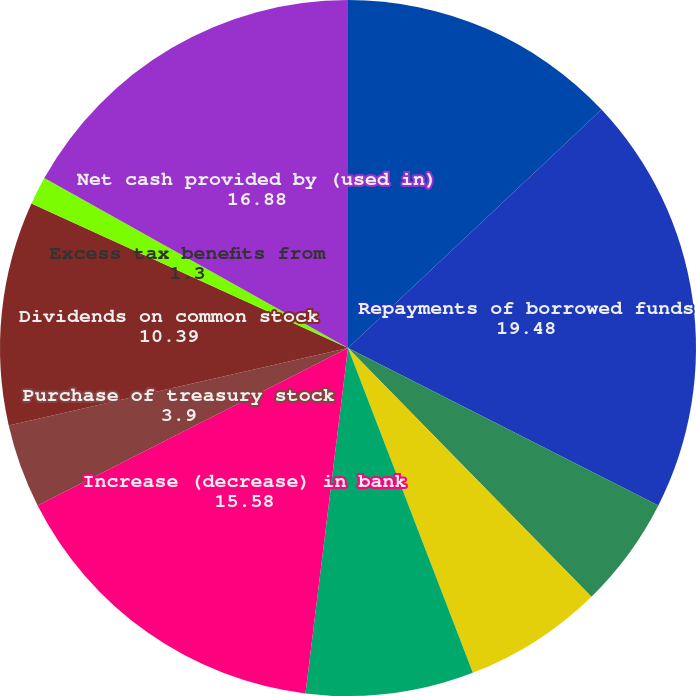Convert chart. <chart><loc_0><loc_0><loc_500><loc_500><pie_chart><fcel>Proceeds from borrowed funds<fcel>Repayments of borrowed funds<fcel>Repayments of borrowings by<fcel>Proceeds from capital<fcel>Exercise of stock options and<fcel>Increase (decrease) in bank<fcel>Purchase of treasury stock<fcel>Dividends on common stock<fcel>Excess tax benefits from<fcel>Net cash provided by (used in)<nl><fcel>12.99%<fcel>19.48%<fcel>5.2%<fcel>6.49%<fcel>7.79%<fcel>15.58%<fcel>3.9%<fcel>10.39%<fcel>1.3%<fcel>16.88%<nl></chart> 